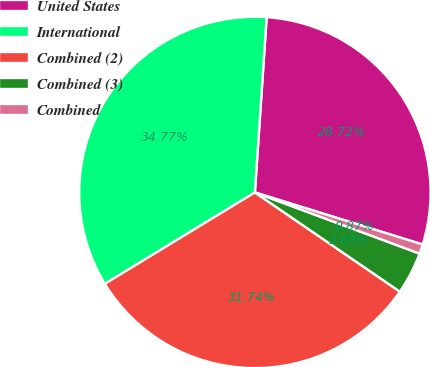Convert chart. <chart><loc_0><loc_0><loc_500><loc_500><pie_chart><fcel>United States<fcel>International<fcel>Combined (2)<fcel>Combined (3)<fcel>Combined<nl><fcel>28.72%<fcel>34.77%<fcel>31.74%<fcel>3.89%<fcel>0.87%<nl></chart> 